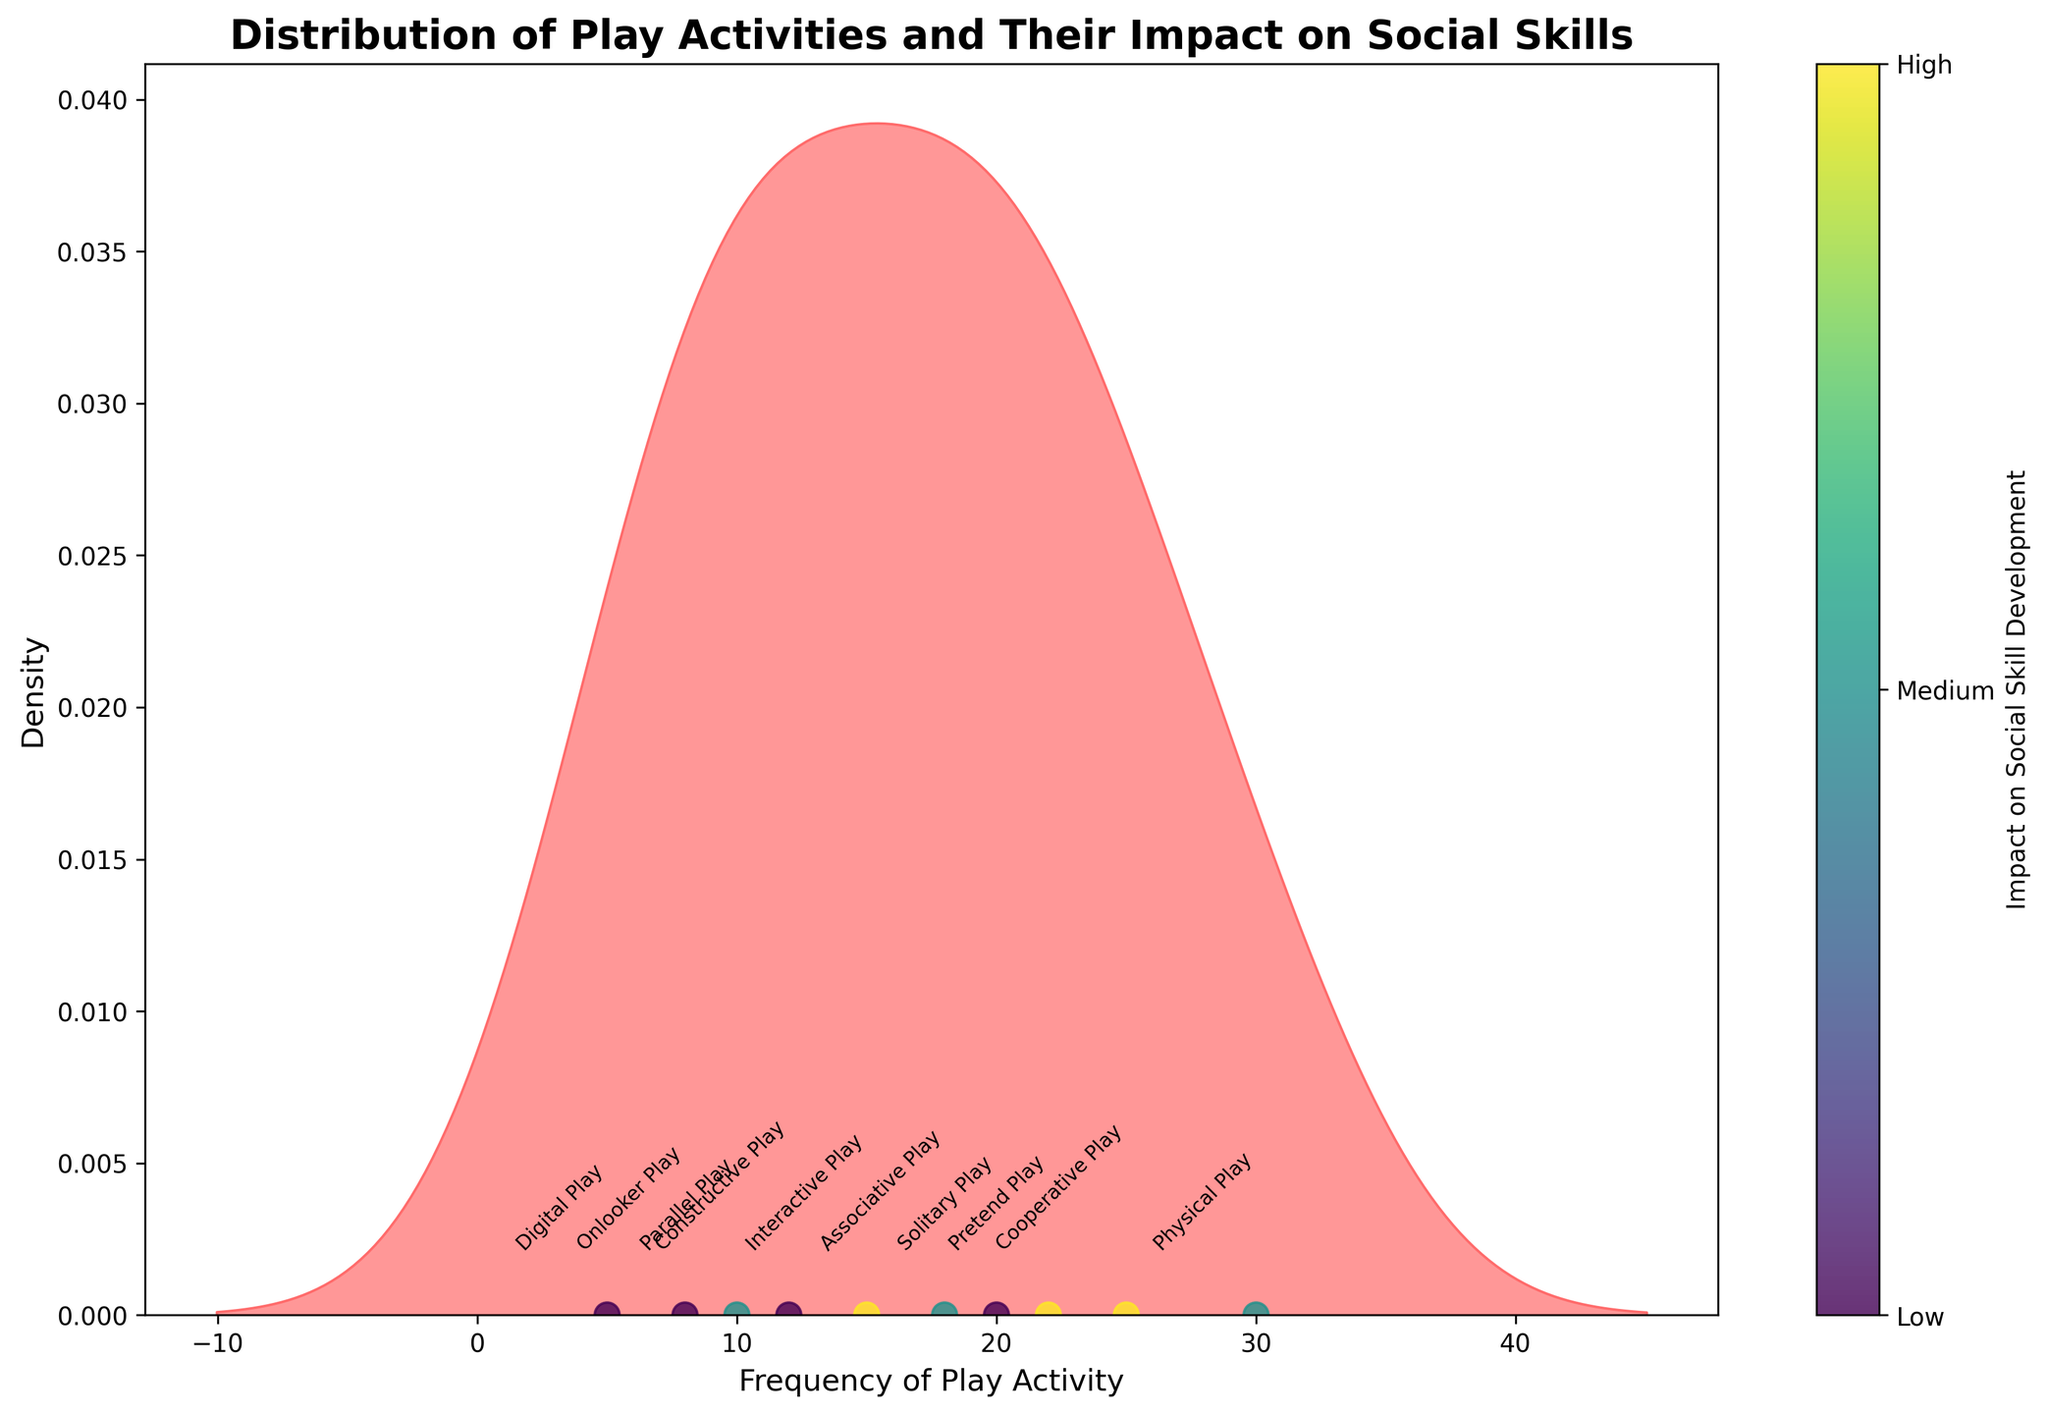Is the type of play with the highest frequency associated with low, medium, or high impact on social skill development? The type of play with the highest frequency is "Physical Play," which looks to be positioned near a color corresponding to 'Medium' impact on social skill development as indicated by the colorbar.
Answer: Medium What is the title of the figure? The title of the figure is located at the top and reads "Distribution of Play Activities and Their Impact on Social Skills," which clearly summarizes the focus of the plotted data.
Answer: Distribution of Play Activities and Their Impact on Social Skills How many play types are associated with a high impact on social skill development? By observing the color coding and texts, we see three distinct color points that correspond to a high impact on social skill development: "Interactive Play," "Cooperative Play," and "Pretend Play."
Answer: Three Which type of play has the lowest frequency and what is its impact on social skill development? The plot shows "Digital Play" at the lowest frequency, close to the lowest end of the x-axis, and it is associated with a color that the legend indicates means low impact on social skill development.
Answer: Digital Play, Low Which play activities fall into the medium impact category on social skill development and what are their frequencies? Reading the color codes and annotations indicates "Parallel Play," "Associative Play," and "Physical Play" fall into the medium category with frequencies of 10, 18, and 30, respectively, as tracked along the x-axis.
Answer: Parallel Play (10), Associative Play (18), Physical Play (30) Which is more frequent, Associative Play or Constructive Play, and what is their impact level? Associative Play, with a frequency of 18, is more frequent than Constructive Play, which has a frequency of 12. Both play types can be traced to different impact levels: medium for "Associative Play" and low for "Constructive Play" based on their color markings.
Answer: Associative Play, Medium; Constructive Play, Low How are the types of play activities with low social skill impact visually represented in terms of their positions and colors? Types such as "Solitary Play," "Constructive Play," "Onlooker Play," and "Digital Play" cluster at the lower frequencies on the x-axis and use the coloring system that maps to 'Low' on the colorbar.
Answer: Lower frequencies, low color What is the median frequency of play activities across the dataset? Arranging the frequencies (5, 8, 10, 12, 15, 18, 20, 22, 25, 30), the median is the middle value in the list. As we have 10 values, the median lies between the 5th and 6th elements, averaging to (15+18)/2 = 16.5
Answer: 16.5 Which type of play with a high impact on social skills has a lower frequency: Cooperative Play or Pretend Play? "Cooperative Play" has a frequency of 25 while "Pretend Play" has a frequency of 22, so between these, "Pretend Play" has a lower frequency. Both are marked with the high impact color.
Answer: Pretend Play Are there any play types that have a frequency of more than 20 and a low impact on social skill development? Observing the frequencies and corresponding color codes, none of the play types exceed a frequency of 20 and have a color indicative of low social skill development impact.
Answer: No 